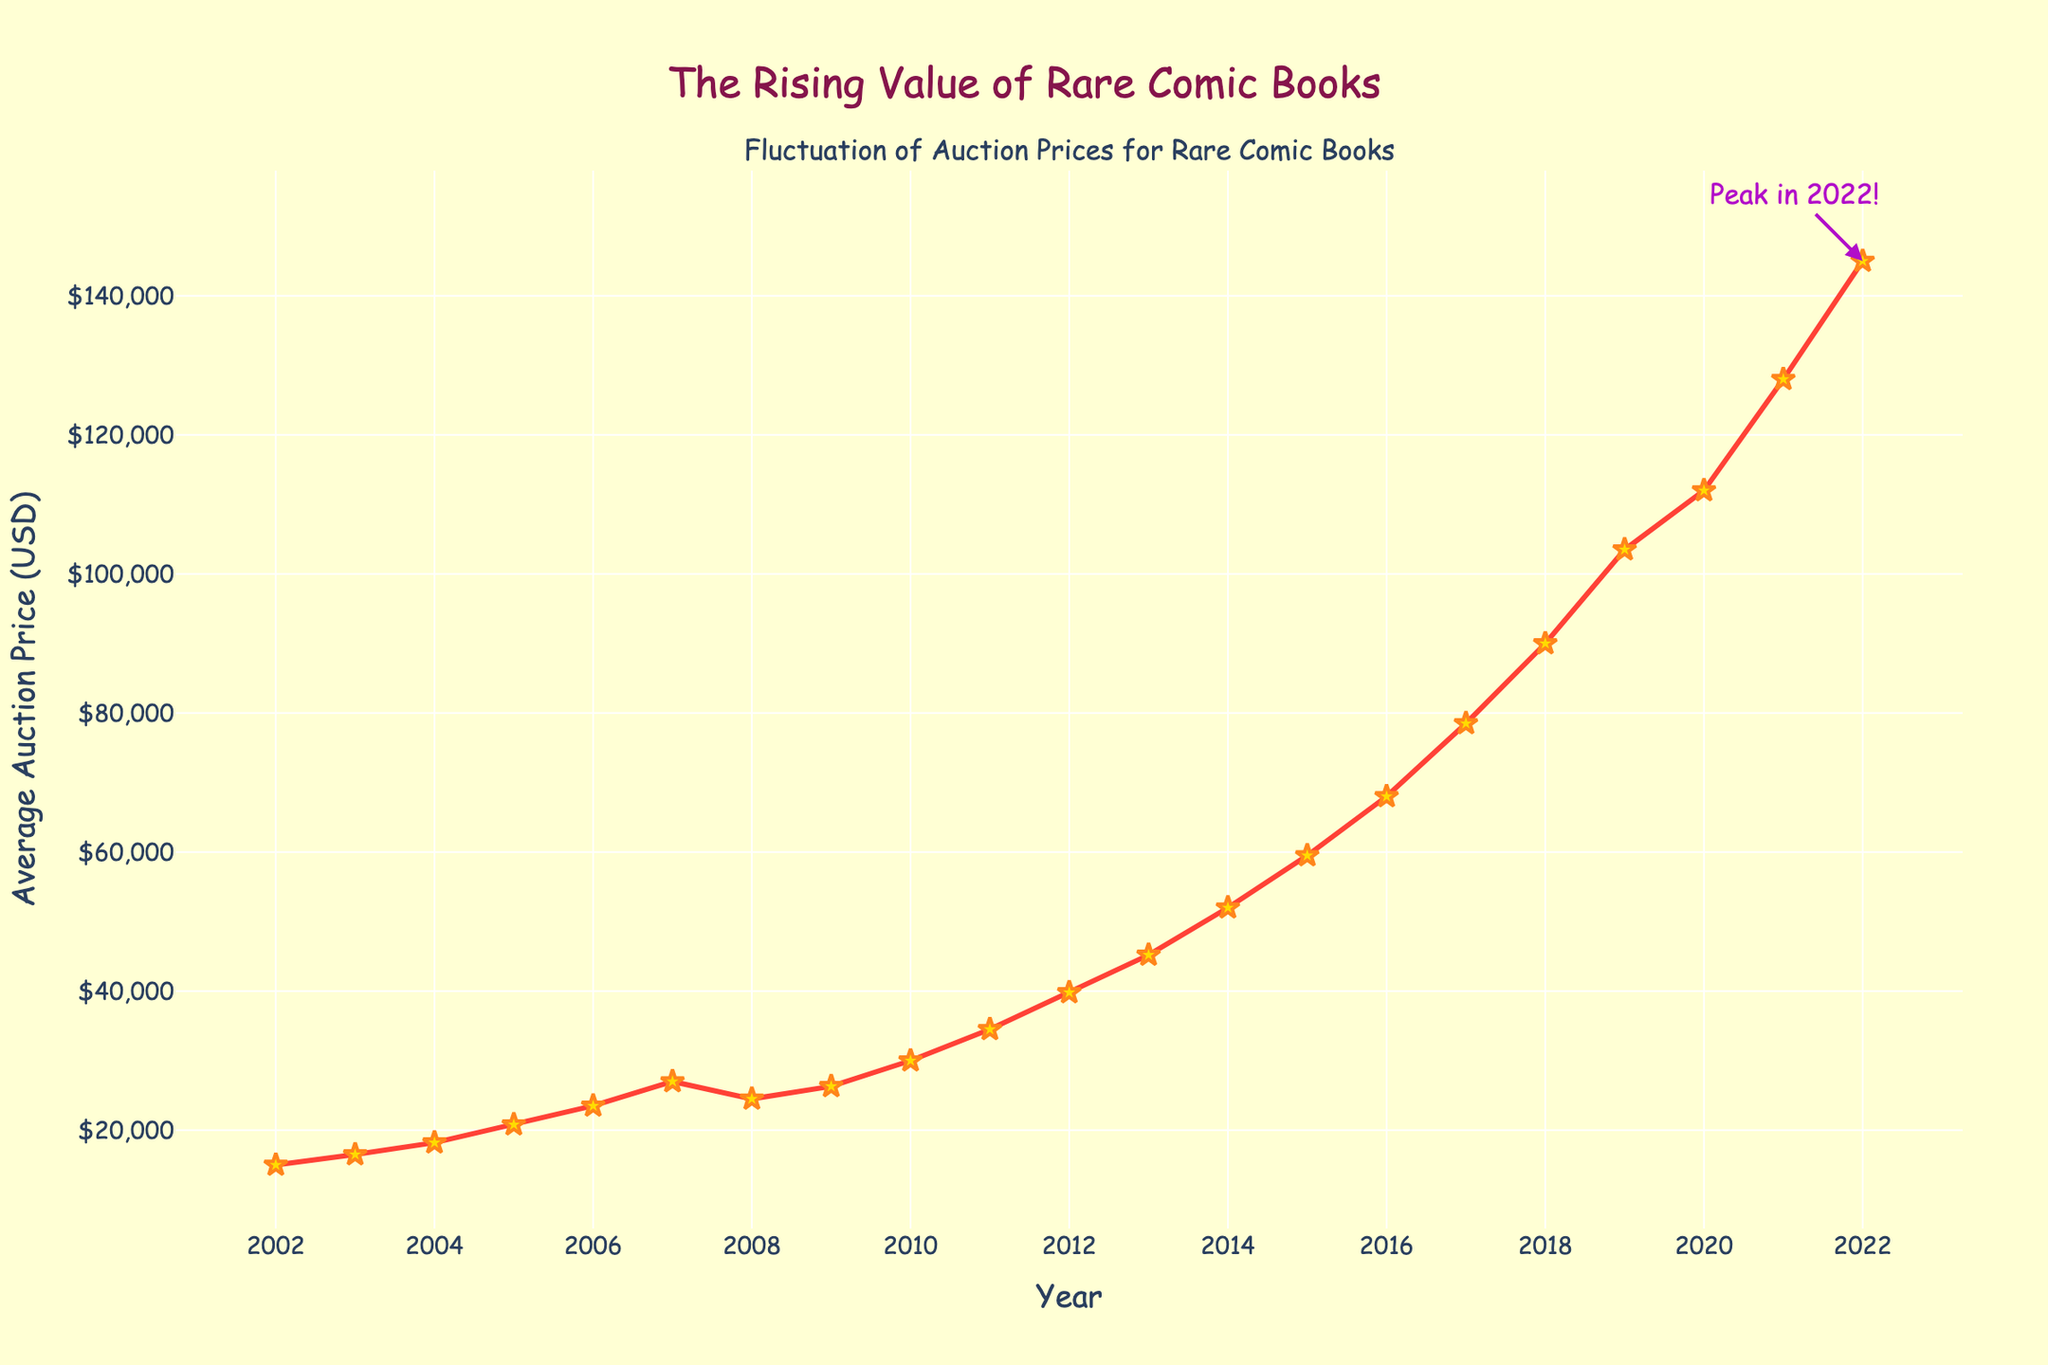What's the highest average auction price recorded? The peak annotation points out that 2022 had the highest average auction price. Looking at the y-axis value at 2022, it is $145,000.
Answer: $145,000 What is the difference in average auction prices between 2010 and 2020? From the chart, the average auction price in 2010 is $30,000 and in 2020 is $112,000. Subtracting these, $112,000 - $30,000 gives us $82,000.
Answer: $82,000 How did the average auction price change from 2008 to 2009? The chart shows a dip from 2008 to 2009. The price in 2008 is $24,500 and in 2009 it's $26,300. The difference is $26,300 - $24,500 = $1,800 increase.
Answer: $1,800 increase What is the trend in average auction prices between 2016 and 2018? The prices were increasing each year. In 2016, the average price is $68,000, in 2017 it is $78,500, and in 2018 it is $90,000. The trend is consistent growth.
Answer: Consistent growth Between which years did the average auction price show the largest increase? From 2021 to 2022, the price grew from $128,000 to $145,000. This is an increment of $17,000, which is the largest increase compared to all other years.
Answer: 2021 to 2022 Which year experienced a drop in average auction prices after a significant increase? In 2008, the price was $24,500, and it dropped to $26,300 in 2009 after an increase from 2007's $27,000.
Answer: 2008 to 2009 What is the average rate of increase per year from 2002 to 2022? The difference in price between 2002 and 2022 is $145,000 - $15,000 = $130,000. There are 20 years between these, so the average rate of increase per year is $130,000/20 = $6,500.
Answer: $6,500 per year What color signifies the peak in 2022 in the chart? The annotation at the peak in 2022 is shown with an arrow and text in purple, highlighting the highest auction price point.
Answer: Purple 